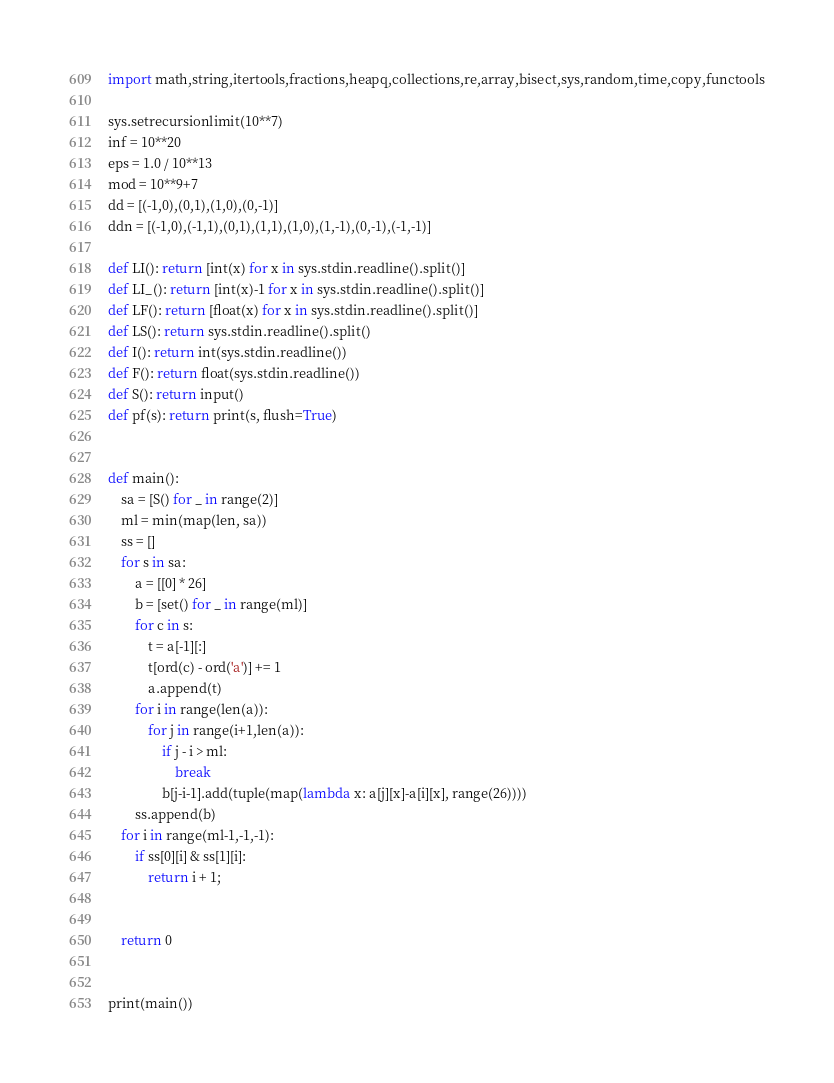Convert code to text. <code><loc_0><loc_0><loc_500><loc_500><_Python_>import math,string,itertools,fractions,heapq,collections,re,array,bisect,sys,random,time,copy,functools

sys.setrecursionlimit(10**7)
inf = 10**20
eps = 1.0 / 10**13
mod = 10**9+7
dd = [(-1,0),(0,1),(1,0),(0,-1)]
ddn = [(-1,0),(-1,1),(0,1),(1,1),(1,0),(1,-1),(0,-1),(-1,-1)]

def LI(): return [int(x) for x in sys.stdin.readline().split()]
def LI_(): return [int(x)-1 for x in sys.stdin.readline().split()]
def LF(): return [float(x) for x in sys.stdin.readline().split()]
def LS(): return sys.stdin.readline().split()
def I(): return int(sys.stdin.readline())
def F(): return float(sys.stdin.readline())
def S(): return input()
def pf(s): return print(s, flush=True)


def main():
    sa = [S() for _ in range(2)]
    ml = min(map(len, sa))
    ss = []
    for s in sa:
        a = [[0] * 26]
        b = [set() for _ in range(ml)]
        for c in s:
            t = a[-1][:]
            t[ord(c) - ord('a')] += 1
            a.append(t)
        for i in range(len(a)):
            for j in range(i+1,len(a)):
                if j - i > ml:
                    break
                b[j-i-1].add(tuple(map(lambda x: a[j][x]-a[i][x], range(26))))
        ss.append(b)
    for i in range(ml-1,-1,-1):
        if ss[0][i] & ss[1][i]:
            return i + 1;


    return 0


print(main())

</code> 